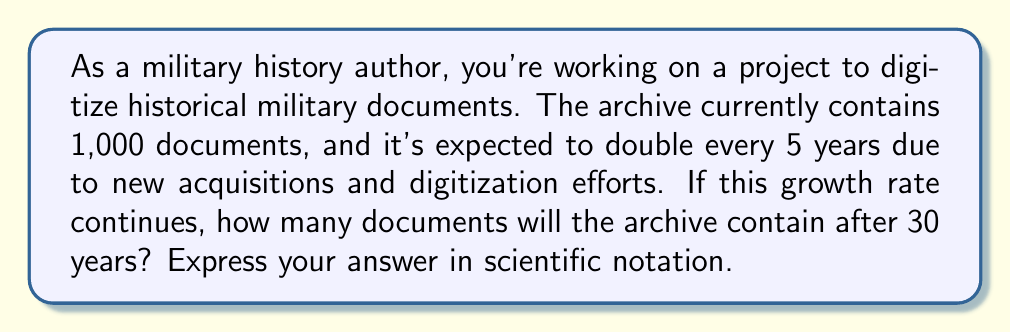Give your solution to this math problem. Let's approach this step-by-step:

1) First, we need to determine how many times the archive will double in 30 years:
   $\frac{30 \text{ years}}{5 \text{ years per doubling}} = 6 \text{ doublings}$

2) Now, we can express this as an exponential equation:
   $1,000 \cdot 2^6$

3) Let's calculate $2^6$:
   $2^6 = 2 \cdot 2 \cdot 2 \cdot 2 \cdot 2 \cdot 2 = 64$

4) Now we multiply:
   $1,000 \cdot 64 = 64,000$

5) To express this in scientific notation, we move the decimal point to the left until we have a number between 1 and 10, and then count how many places we moved:
   $64,000 = 6.4 \cdot 10^4$

Thus, after 30 years, the archive will contain $6.4 \cdot 10^4$ documents.
Answer: $6.4 \cdot 10^4$ documents 